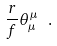<formula> <loc_0><loc_0><loc_500><loc_500>\frac { r } { f } \theta _ { \mu } ^ { \mu } \ .</formula> 